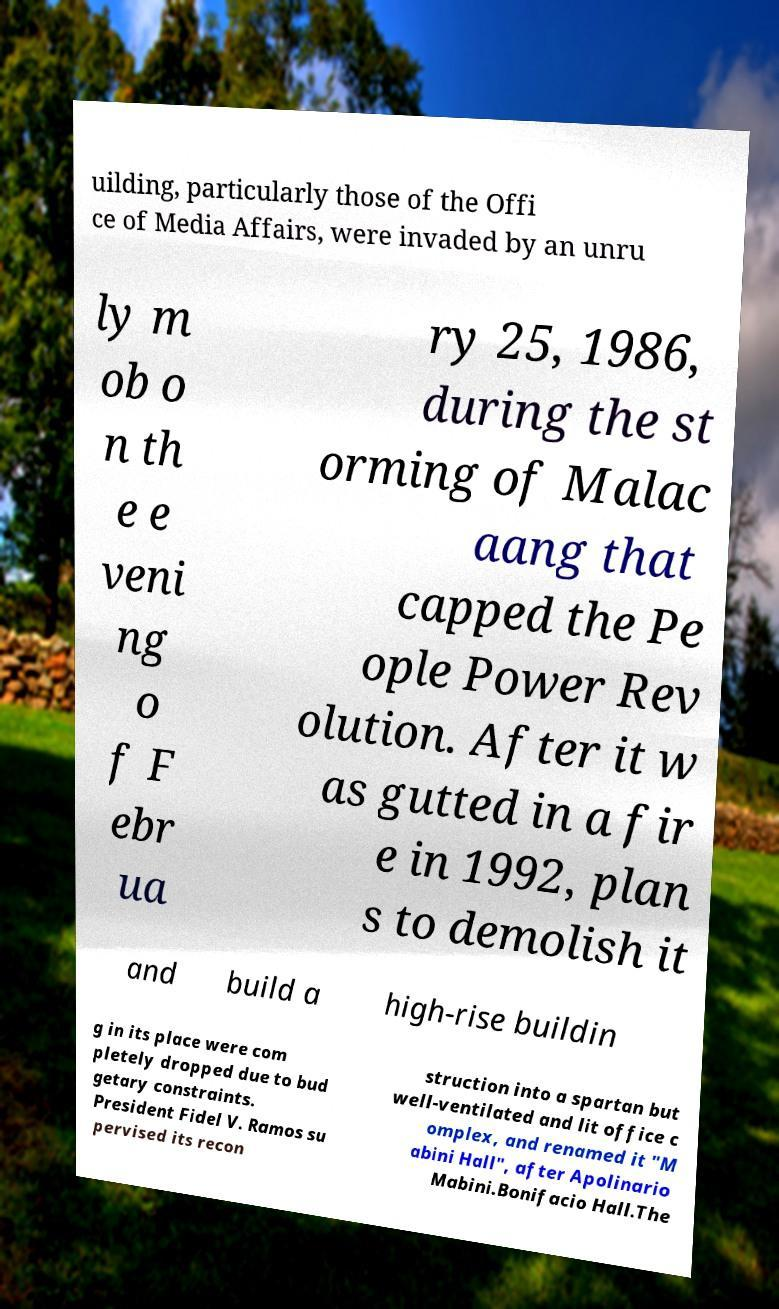What messages or text are displayed in this image? I need them in a readable, typed format. uilding, particularly those of the Offi ce of Media Affairs, were invaded by an unru ly m ob o n th e e veni ng o f F ebr ua ry 25, 1986, during the st orming of Malac aang that capped the Pe ople Power Rev olution. After it w as gutted in a fir e in 1992, plan s to demolish it and build a high-rise buildin g in its place were com pletely dropped due to bud getary constraints. President Fidel V. Ramos su pervised its recon struction into a spartan but well-ventilated and lit office c omplex, and renamed it "M abini Hall", after Apolinario Mabini.Bonifacio Hall.The 